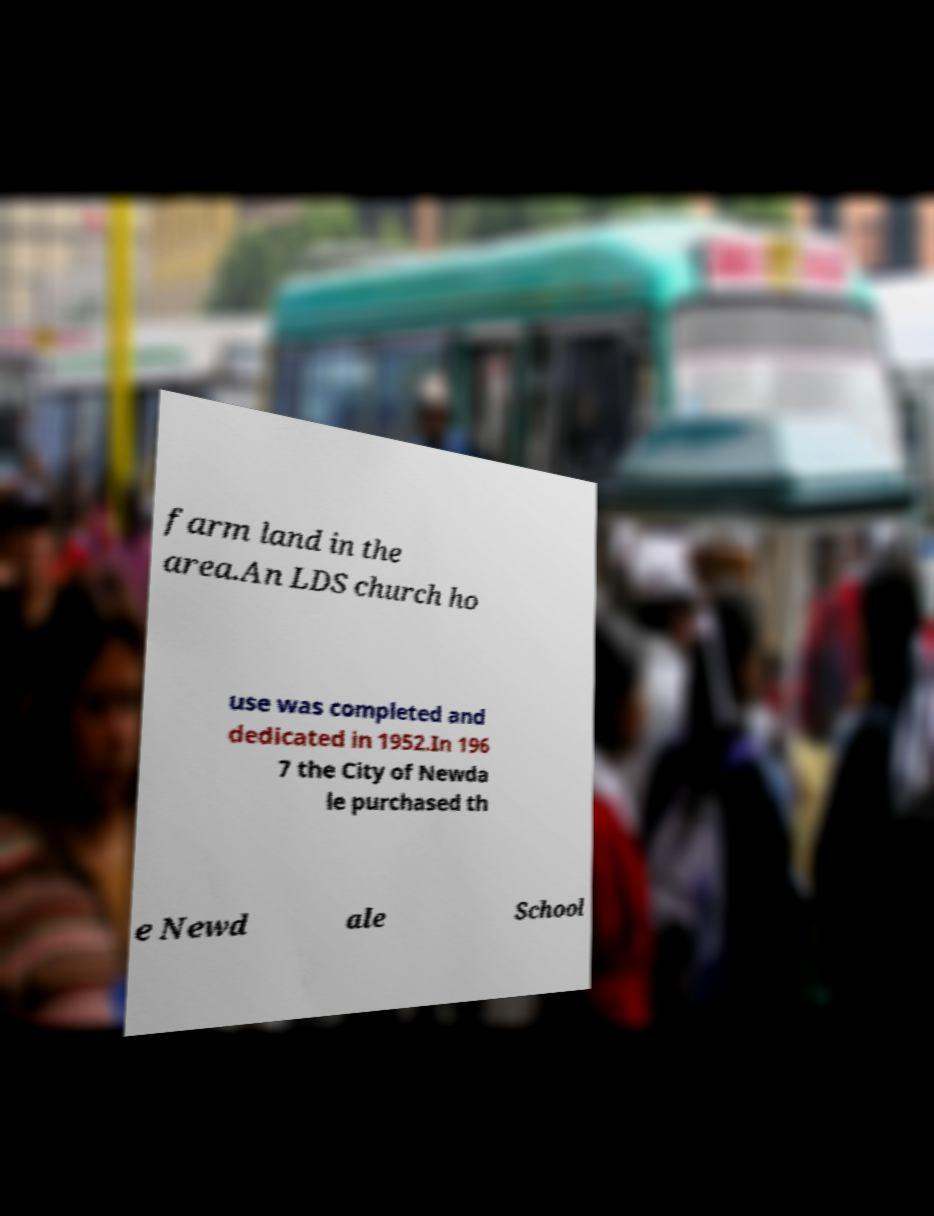I need the written content from this picture converted into text. Can you do that? farm land in the area.An LDS church ho use was completed and dedicated in 1952.In 196 7 the City of Newda le purchased th e Newd ale School 